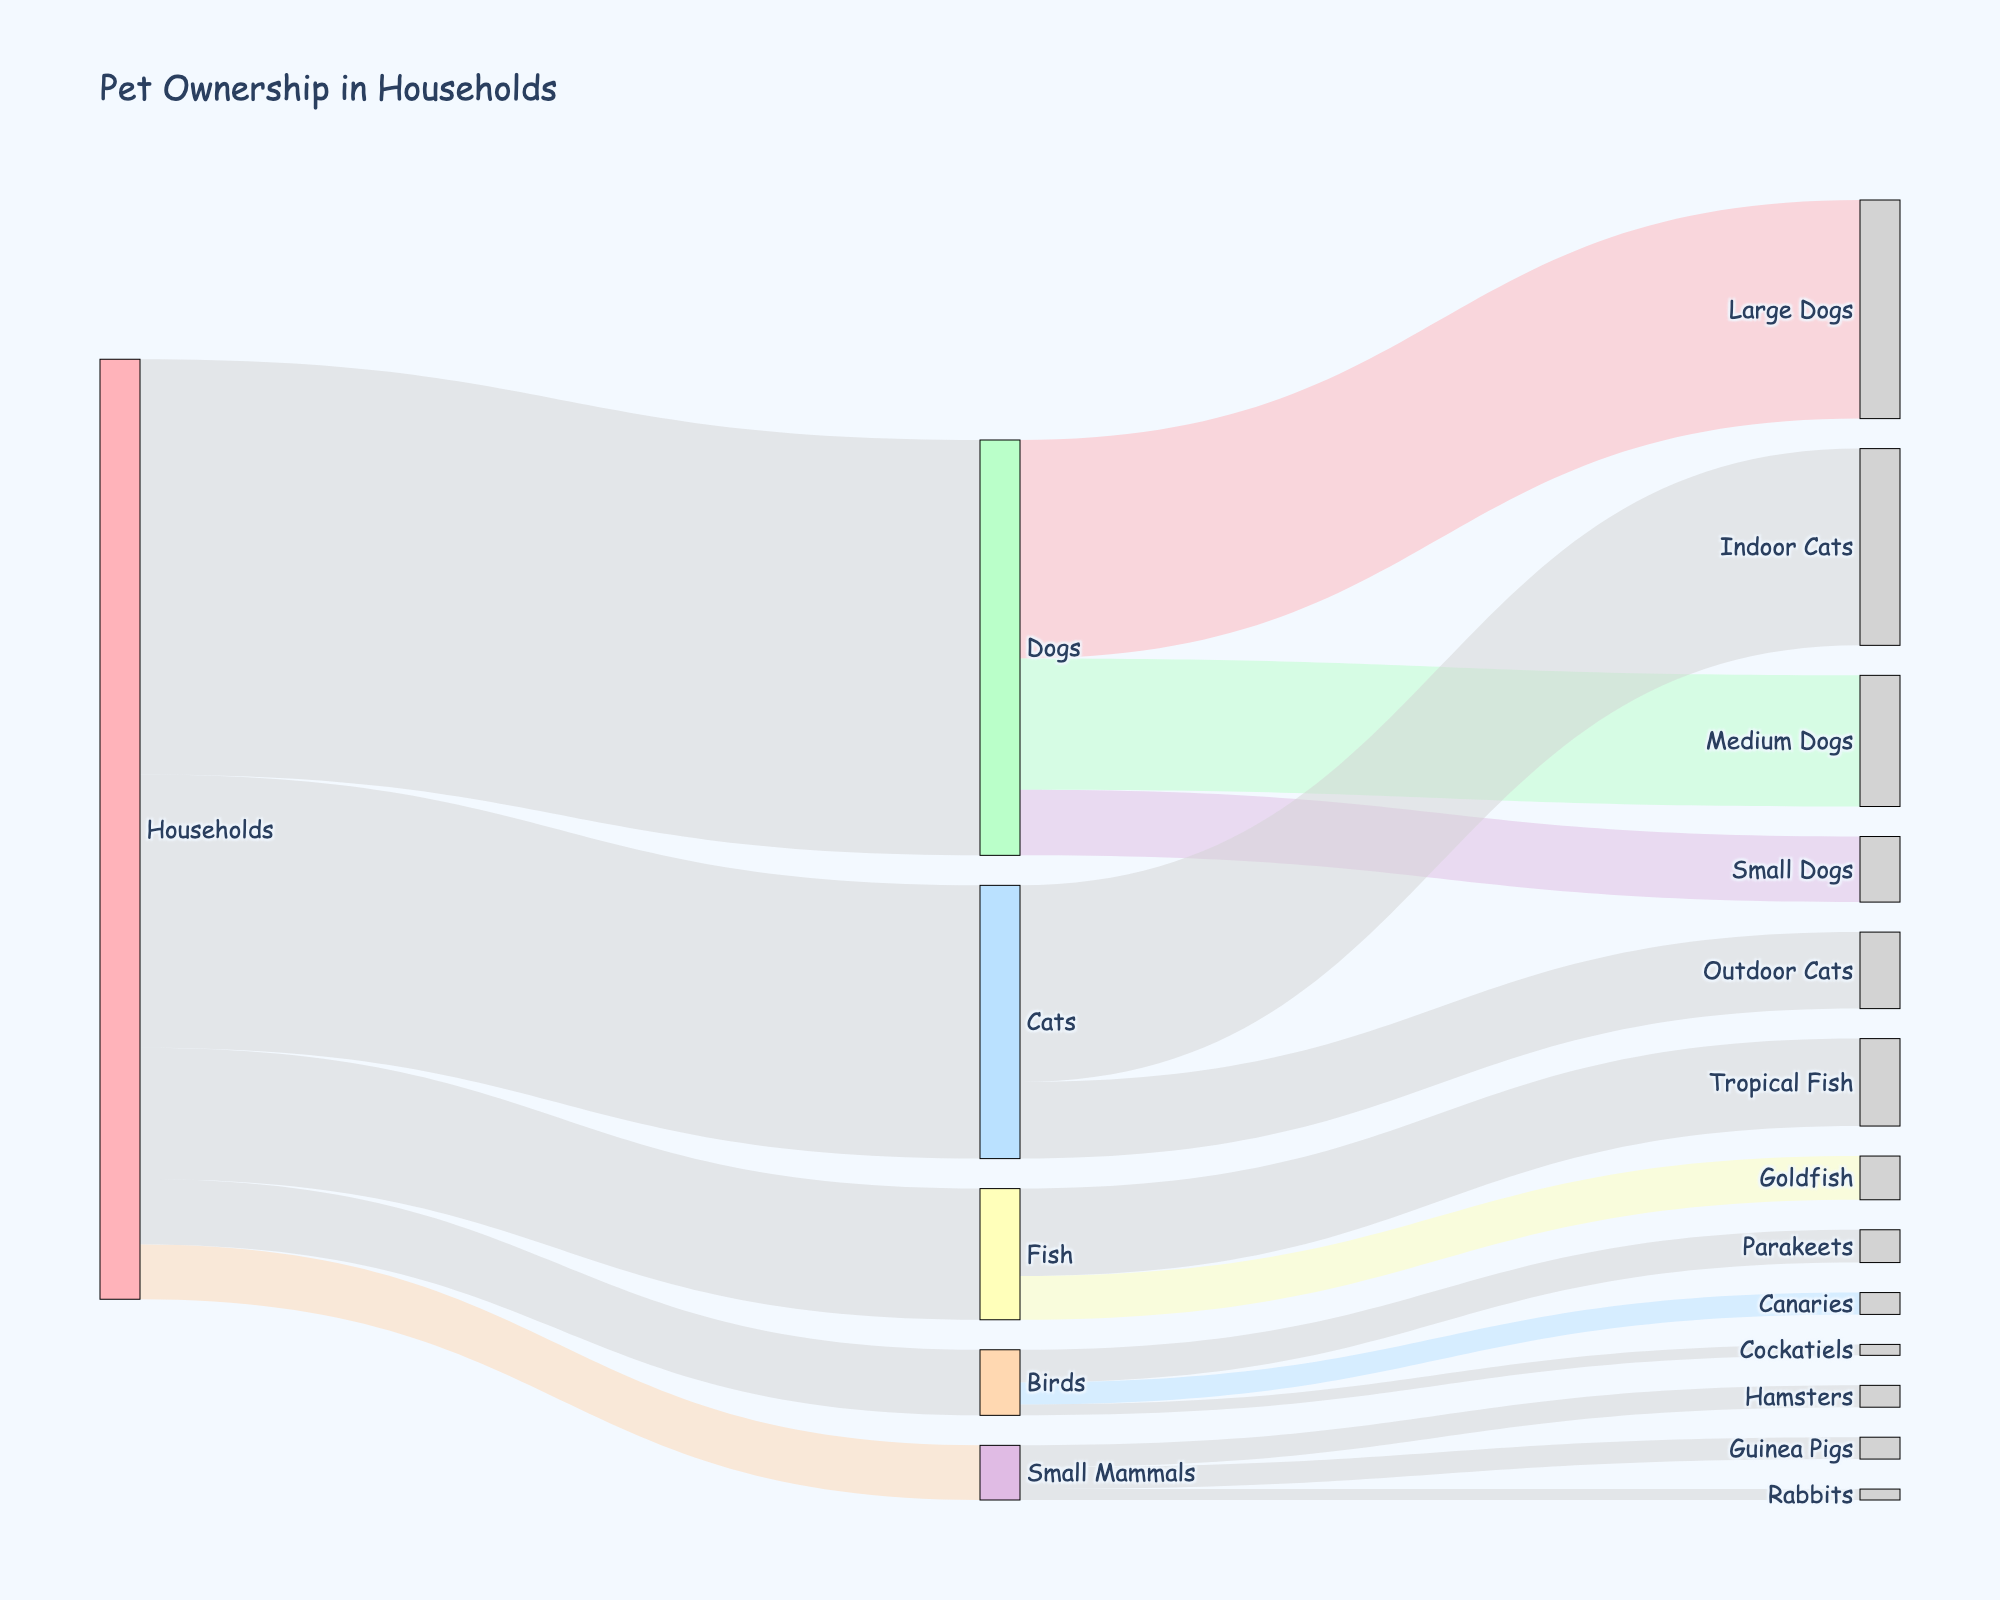what is the most popular pet type in households? The label "Households" sends the largest flow to "Dogs," indicating that it is the most popular pet type.
Answer: Dogs How many more households have dogs compared to small mammals? Look at the value of the link between "Households" and "Dogs" which is 38, and the value between "Households" and "Small Mammals" which is 5. Calculate the difference: 38 - 5.
Answer: 33 What does the color pink represent in the diagram? The color pink corresponds to the "Households" label in the diagram as indicated by the color dictionary.
Answer: Households How many households own indoor cats? Trace the link from "Households" to "Cats" (25) and then from "Cats" to "Indoor Cats" (18). The flow of 18 represents households with indoor cats.
Answer: 18 Which is more common in households, parakeets or rabbits? Identify the values of the links for "Parakeets" (3) and "Rabbits" (1). Since 3 is greater than 1, parakeets are more common.
Answer: Parakeets What is the total number of fish in households? Identify the flow values between "Households" and "Fish" which is 12. Separate flows for tropical fish (8) and goldfish (4) sum up to the total number: 8 + 4.
Answer: 12 Which pet type has the least variety within its category? Compare sub-categories within each pet type: Dogs (Large, Medium, Small), Cats (Indoor, Outdoor), Fish (Tropical, Goldfish), Birds (Parakeets, Canaries, Cockatiels), Small Mammals (Hamsters, Guinea Pigs, Rabbits). Small Mammals have the least variety with 3 types.
Answer: Small Mammals How many more medium dogs are there compared to small dogs? Identify the flow value for "Medium Dogs" (12) and "Small Dogs" (6). Calculate the difference: 12 - 6.
Answer: 6 